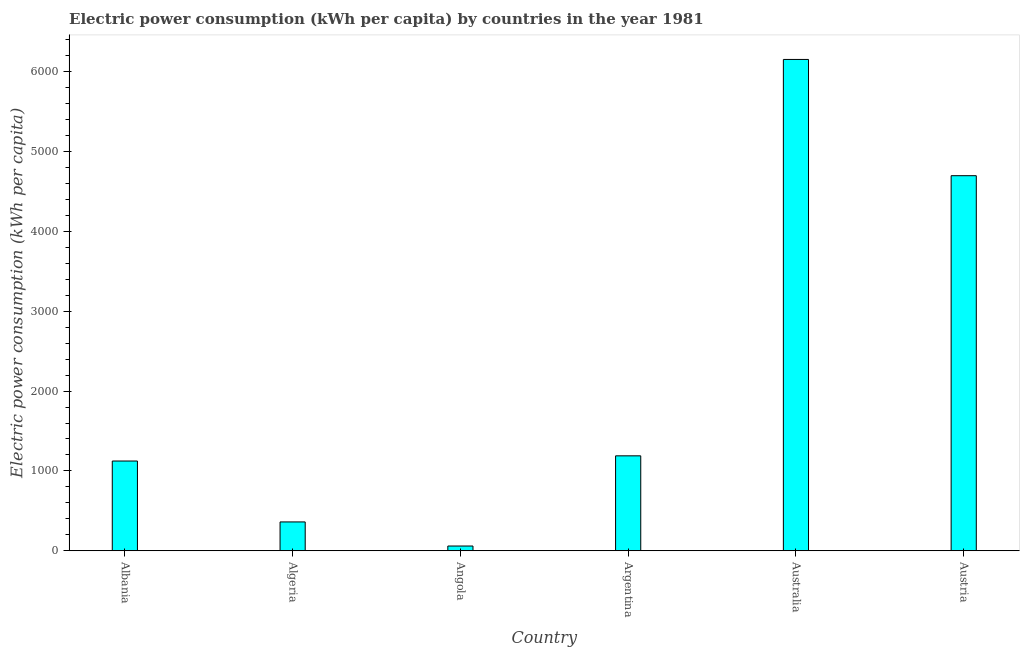Does the graph contain any zero values?
Your answer should be very brief. No. Does the graph contain grids?
Provide a short and direct response. No. What is the title of the graph?
Offer a terse response. Electric power consumption (kWh per capita) by countries in the year 1981. What is the label or title of the X-axis?
Offer a very short reply. Country. What is the label or title of the Y-axis?
Offer a very short reply. Electric power consumption (kWh per capita). What is the electric power consumption in Algeria?
Ensure brevity in your answer.  361.27. Across all countries, what is the maximum electric power consumption?
Provide a short and direct response. 6153.35. Across all countries, what is the minimum electric power consumption?
Give a very brief answer. 59.54. In which country was the electric power consumption minimum?
Your answer should be very brief. Angola. What is the sum of the electric power consumption?
Give a very brief answer. 1.36e+04. What is the difference between the electric power consumption in Albania and Algeria?
Provide a short and direct response. 762.7. What is the average electric power consumption per country?
Keep it short and to the point. 2264.08. What is the median electric power consumption?
Your answer should be compact. 1156.48. In how many countries, is the electric power consumption greater than 3600 kWh per capita?
Your response must be concise. 2. What is the ratio of the electric power consumption in Albania to that in Angola?
Your response must be concise. 18.88. Is the electric power consumption in Argentina less than that in Austria?
Keep it short and to the point. Yes. Is the difference between the electric power consumption in Algeria and Angola greater than the difference between any two countries?
Provide a succinct answer. No. What is the difference between the highest and the second highest electric power consumption?
Provide a short and direct response. 1455.98. Is the sum of the electric power consumption in Algeria and Angola greater than the maximum electric power consumption across all countries?
Your answer should be very brief. No. What is the difference between the highest and the lowest electric power consumption?
Ensure brevity in your answer.  6093.8. How many bars are there?
Your answer should be compact. 6. Are all the bars in the graph horizontal?
Your answer should be compact. No. What is the difference between two consecutive major ticks on the Y-axis?
Provide a succinct answer. 1000. Are the values on the major ticks of Y-axis written in scientific E-notation?
Keep it short and to the point. No. What is the Electric power consumption (kWh per capita) in Albania?
Keep it short and to the point. 1123.97. What is the Electric power consumption (kWh per capita) in Algeria?
Your answer should be compact. 361.27. What is the Electric power consumption (kWh per capita) of Angola?
Your answer should be very brief. 59.54. What is the Electric power consumption (kWh per capita) of Argentina?
Give a very brief answer. 1189. What is the Electric power consumption (kWh per capita) in Australia?
Offer a terse response. 6153.35. What is the Electric power consumption (kWh per capita) in Austria?
Ensure brevity in your answer.  4697.37. What is the difference between the Electric power consumption (kWh per capita) in Albania and Algeria?
Ensure brevity in your answer.  762.7. What is the difference between the Electric power consumption (kWh per capita) in Albania and Angola?
Your answer should be very brief. 1064.42. What is the difference between the Electric power consumption (kWh per capita) in Albania and Argentina?
Your answer should be compact. -65.03. What is the difference between the Electric power consumption (kWh per capita) in Albania and Australia?
Your answer should be very brief. -5029.38. What is the difference between the Electric power consumption (kWh per capita) in Albania and Austria?
Keep it short and to the point. -3573.4. What is the difference between the Electric power consumption (kWh per capita) in Algeria and Angola?
Provide a succinct answer. 301.72. What is the difference between the Electric power consumption (kWh per capita) in Algeria and Argentina?
Keep it short and to the point. -827.73. What is the difference between the Electric power consumption (kWh per capita) in Algeria and Australia?
Offer a terse response. -5792.08. What is the difference between the Electric power consumption (kWh per capita) in Algeria and Austria?
Offer a terse response. -4336.1. What is the difference between the Electric power consumption (kWh per capita) in Angola and Argentina?
Your answer should be compact. -1129.45. What is the difference between the Electric power consumption (kWh per capita) in Angola and Australia?
Your answer should be compact. -6093.8. What is the difference between the Electric power consumption (kWh per capita) in Angola and Austria?
Make the answer very short. -4637.82. What is the difference between the Electric power consumption (kWh per capita) in Argentina and Australia?
Your response must be concise. -4964.35. What is the difference between the Electric power consumption (kWh per capita) in Argentina and Austria?
Your response must be concise. -3508.37. What is the difference between the Electric power consumption (kWh per capita) in Australia and Austria?
Your response must be concise. 1455.98. What is the ratio of the Electric power consumption (kWh per capita) in Albania to that in Algeria?
Offer a very short reply. 3.11. What is the ratio of the Electric power consumption (kWh per capita) in Albania to that in Angola?
Offer a terse response. 18.88. What is the ratio of the Electric power consumption (kWh per capita) in Albania to that in Argentina?
Offer a very short reply. 0.94. What is the ratio of the Electric power consumption (kWh per capita) in Albania to that in Australia?
Provide a succinct answer. 0.18. What is the ratio of the Electric power consumption (kWh per capita) in Albania to that in Austria?
Offer a very short reply. 0.24. What is the ratio of the Electric power consumption (kWh per capita) in Algeria to that in Angola?
Keep it short and to the point. 6.07. What is the ratio of the Electric power consumption (kWh per capita) in Algeria to that in Argentina?
Provide a short and direct response. 0.3. What is the ratio of the Electric power consumption (kWh per capita) in Algeria to that in Australia?
Offer a very short reply. 0.06. What is the ratio of the Electric power consumption (kWh per capita) in Algeria to that in Austria?
Provide a short and direct response. 0.08. What is the ratio of the Electric power consumption (kWh per capita) in Angola to that in Australia?
Give a very brief answer. 0.01. What is the ratio of the Electric power consumption (kWh per capita) in Angola to that in Austria?
Give a very brief answer. 0.01. What is the ratio of the Electric power consumption (kWh per capita) in Argentina to that in Australia?
Your response must be concise. 0.19. What is the ratio of the Electric power consumption (kWh per capita) in Argentina to that in Austria?
Offer a very short reply. 0.25. What is the ratio of the Electric power consumption (kWh per capita) in Australia to that in Austria?
Ensure brevity in your answer.  1.31. 